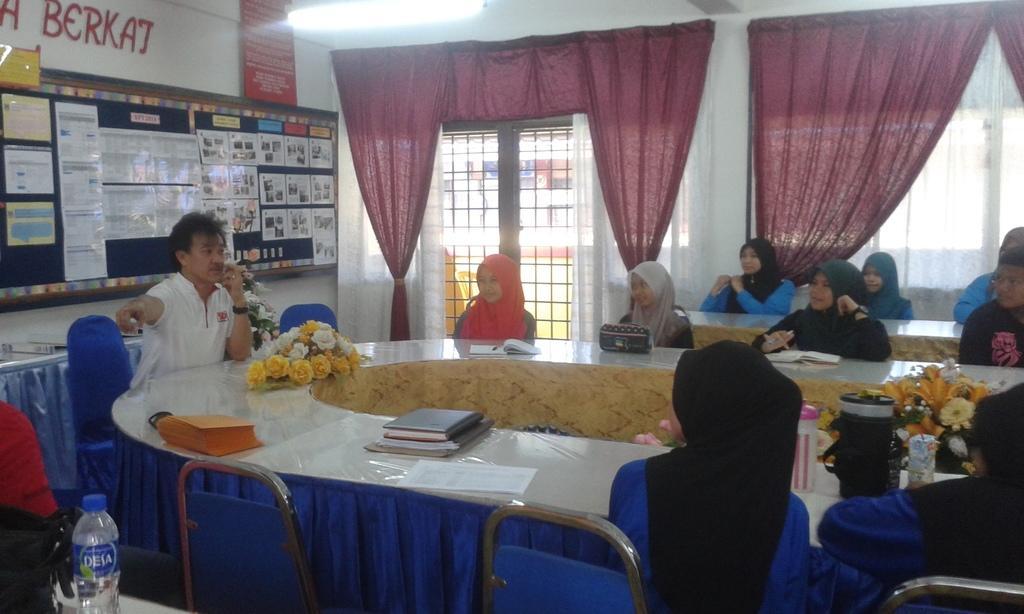How would you summarize this image in a sentence or two? This picture consists of big round table and chairs. There are few people sitting on chairs. On the table there are books, papers, bottles, bags and flowers. On the below left corner of the image there is a handbag and bottle placed on the table. there is a board and big notice board hanging on the wall. In the background there is wall, windows and curtains. 